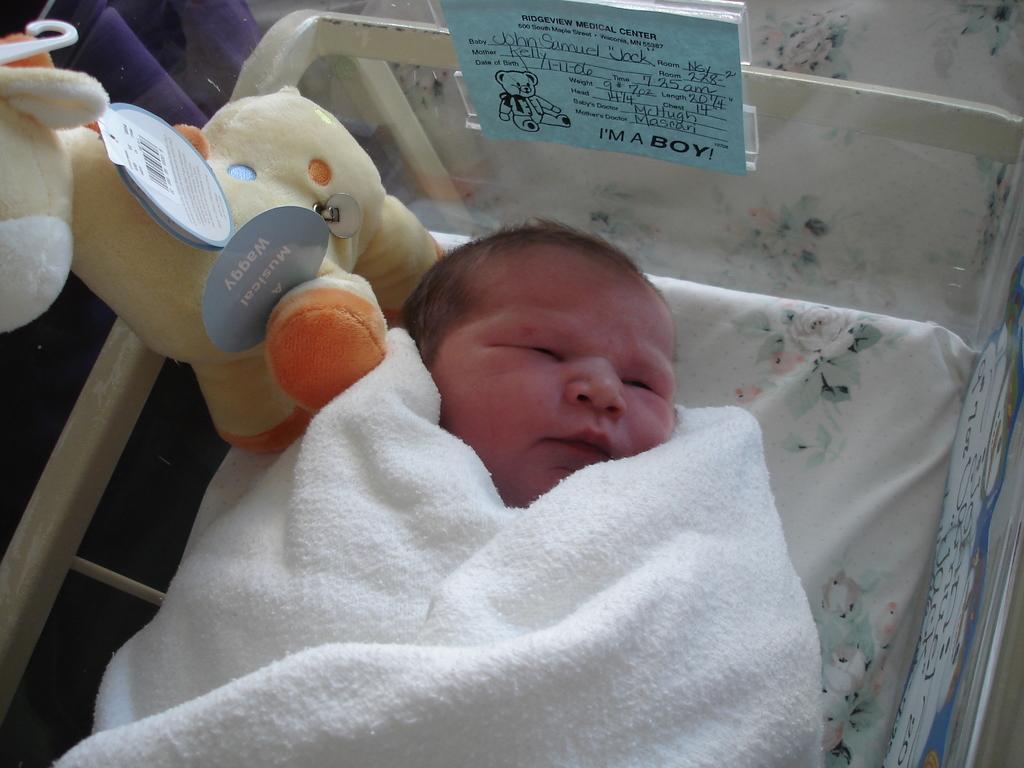Describe this image in one or two sentences. In the image there is an infant sleeping in a cradle, there is a toy kept beside the infant, he is wrapped in a towel. 